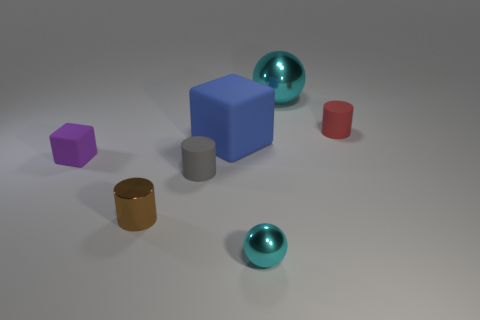Add 1 yellow objects. How many objects exist? 8 Subtract all cylinders. How many objects are left? 4 Subtract all brown metal things. Subtract all brown cylinders. How many objects are left? 5 Add 6 small red matte objects. How many small red matte objects are left? 7 Add 3 small metal spheres. How many small metal spheres exist? 4 Subtract 0 gray spheres. How many objects are left? 7 